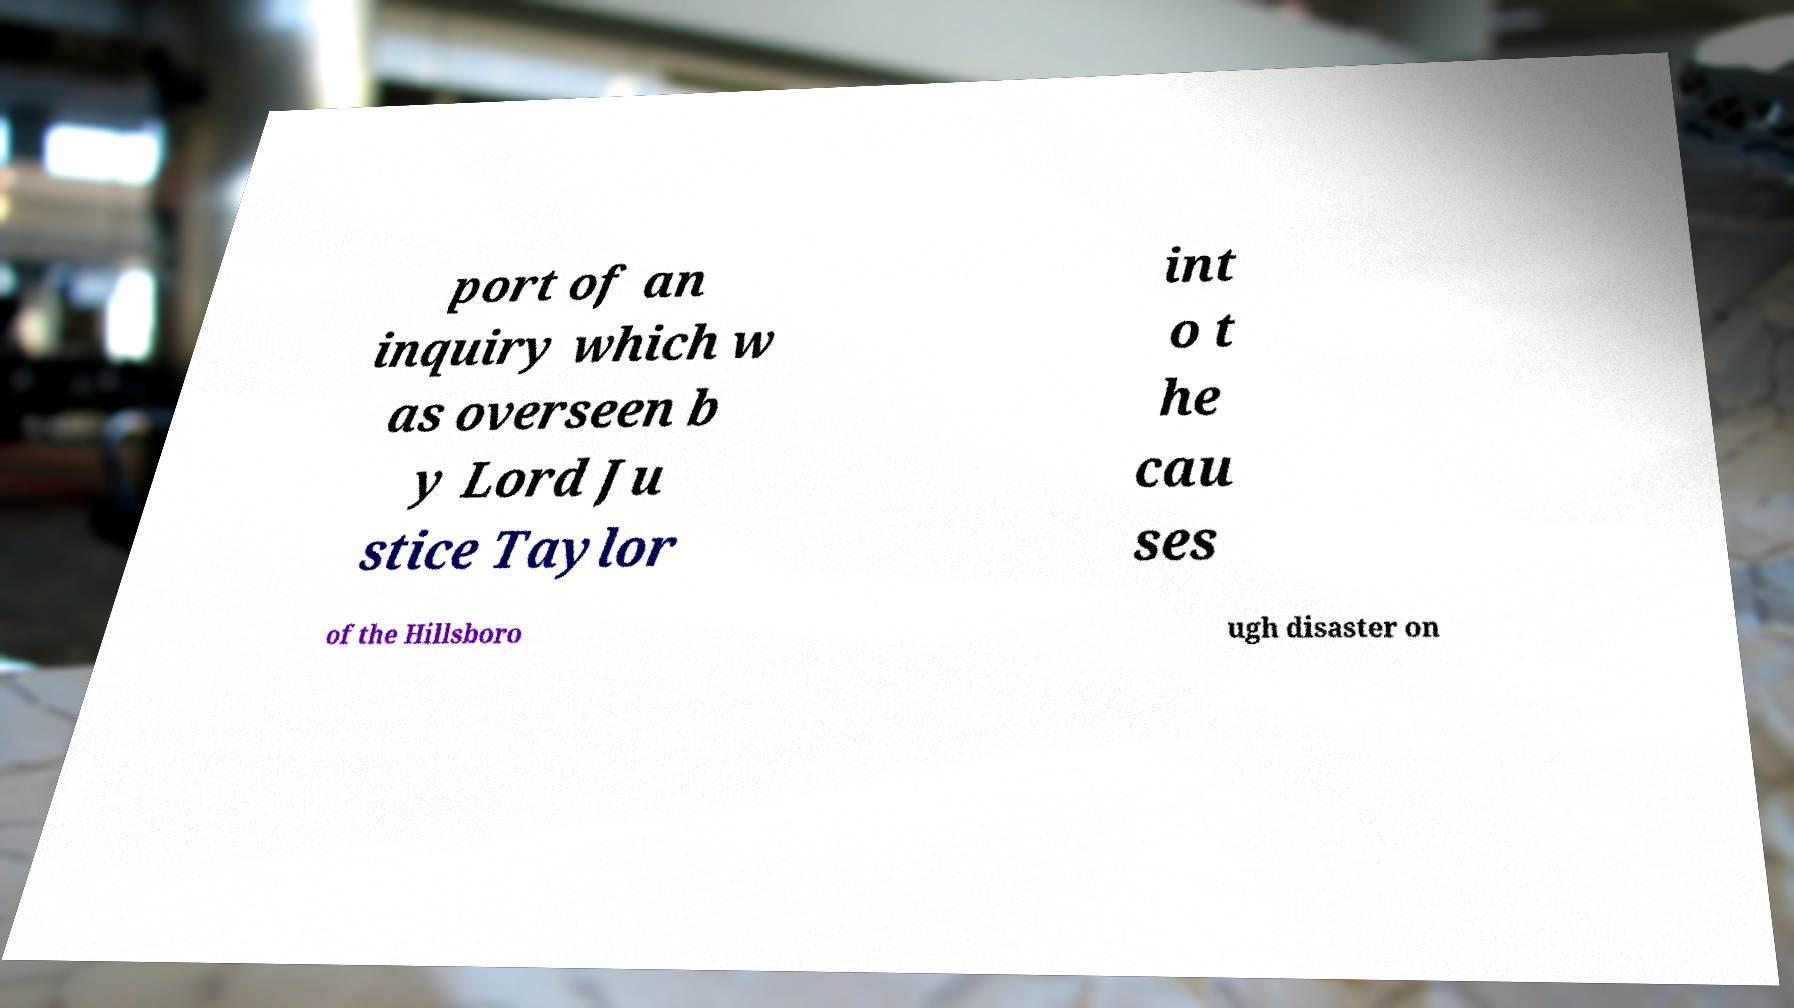Please identify and transcribe the text found in this image. port of an inquiry which w as overseen b y Lord Ju stice Taylor int o t he cau ses of the Hillsboro ugh disaster on 